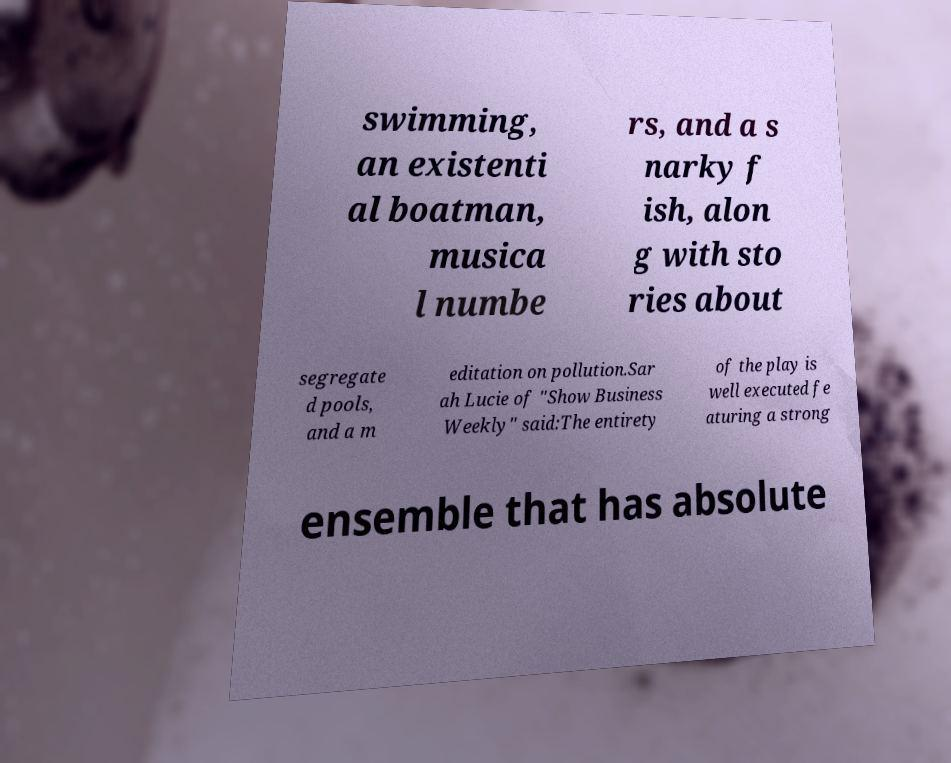Can you read and provide the text displayed in the image?This photo seems to have some interesting text. Can you extract and type it out for me? swimming, an existenti al boatman, musica l numbe rs, and a s narky f ish, alon g with sto ries about segregate d pools, and a m editation on pollution.Sar ah Lucie of "Show Business Weekly" said:The entirety of the play is well executed fe aturing a strong ensemble that has absolute 